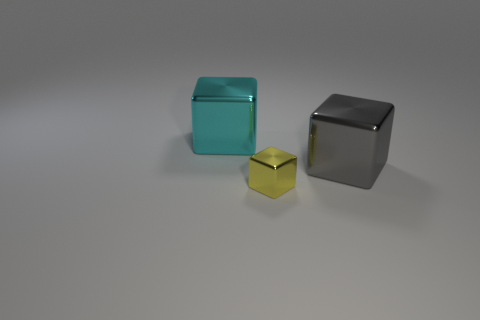Are there more small metal cubes than large cubes?
Provide a succinct answer. No. How many objects are either big things in front of the cyan cube or large gray things behind the yellow block?
Provide a short and direct response. 1. What color is the other block that is the same size as the cyan metallic cube?
Provide a succinct answer. Gray. Do the gray object and the large cyan block have the same material?
Give a very brief answer. Yes. What is the block behind the cube on the right side of the small shiny thing made of?
Offer a very short reply. Metal. Are there more cyan blocks that are on the left side of the large gray block than large cyan rubber cylinders?
Provide a succinct answer. Yes. What number of other objects are the same size as the cyan metal cube?
Provide a succinct answer. 1. There is a large block behind the large metal thing in front of the cyan metallic cube behind the yellow metallic thing; what is its color?
Provide a short and direct response. Cyan. What number of large cubes are right of the big cube that is behind the large shiny object that is to the right of the cyan cube?
Your response must be concise. 1. Is there anything else of the same color as the tiny metallic cube?
Your response must be concise. No. 